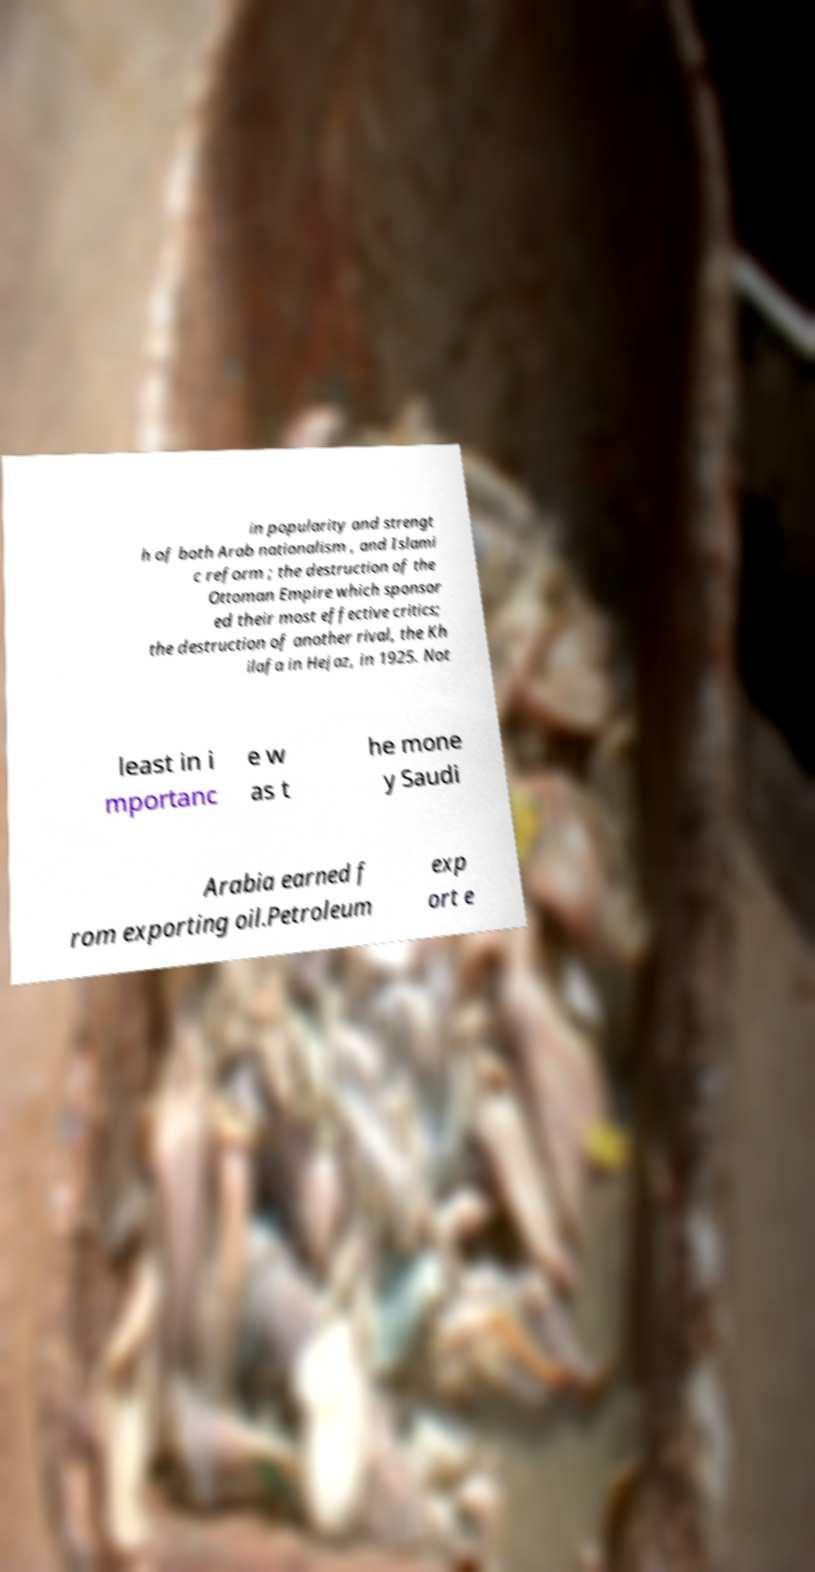Please identify and transcribe the text found in this image. in popularity and strengt h of both Arab nationalism , and Islami c reform ; the destruction of the Ottoman Empire which sponsor ed their most effective critics; the destruction of another rival, the Kh ilafa in Hejaz, in 1925. Not least in i mportanc e w as t he mone y Saudi Arabia earned f rom exporting oil.Petroleum exp ort e 